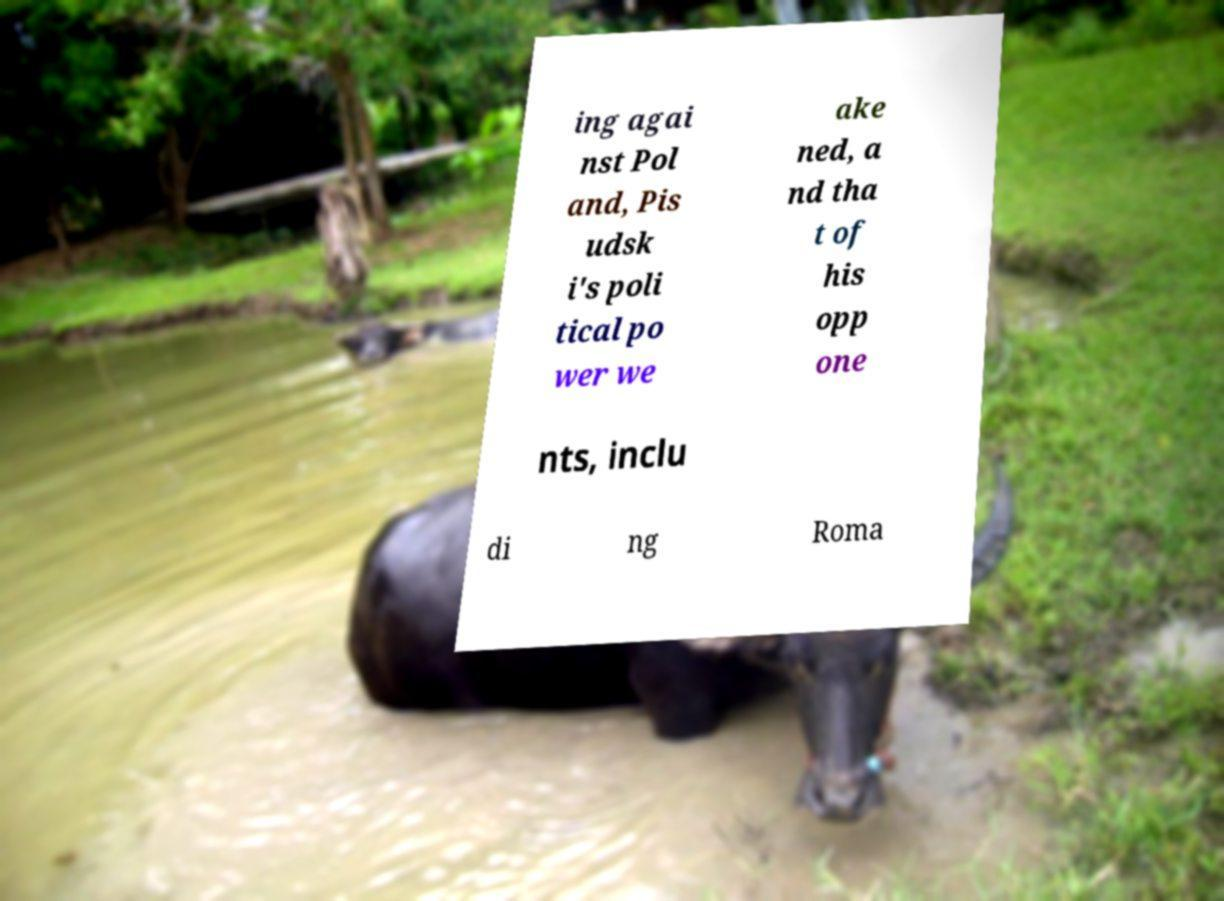For documentation purposes, I need the text within this image transcribed. Could you provide that? ing agai nst Pol and, Pis udsk i's poli tical po wer we ake ned, a nd tha t of his opp one nts, inclu di ng Roma 